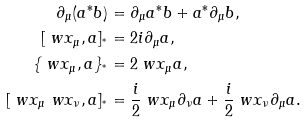Convert formula to latex. <formula><loc_0><loc_0><loc_500><loc_500>\partial _ { \mu } ( a ^ { * } b ) & = \partial _ { \mu } a ^ { * } b + a ^ { * } \partial _ { \mu } b , \\ [ \ w x _ { \mu } , a ] _ { ^ { * } } & = 2 i \partial _ { \mu } a , \\ \{ \ w x _ { \mu } , a \} _ { ^ { * } } & = 2 \ w x _ { \mu } a , \\ [ \ w x _ { \mu } \ w x _ { \nu } , a ] _ { ^ { * } } & = \frac { i } { 2 } \ w x _ { \mu } \partial _ { \nu } a + \frac { i } { 2 } \ w x _ { \nu } \partial _ { \mu } a .</formula> 